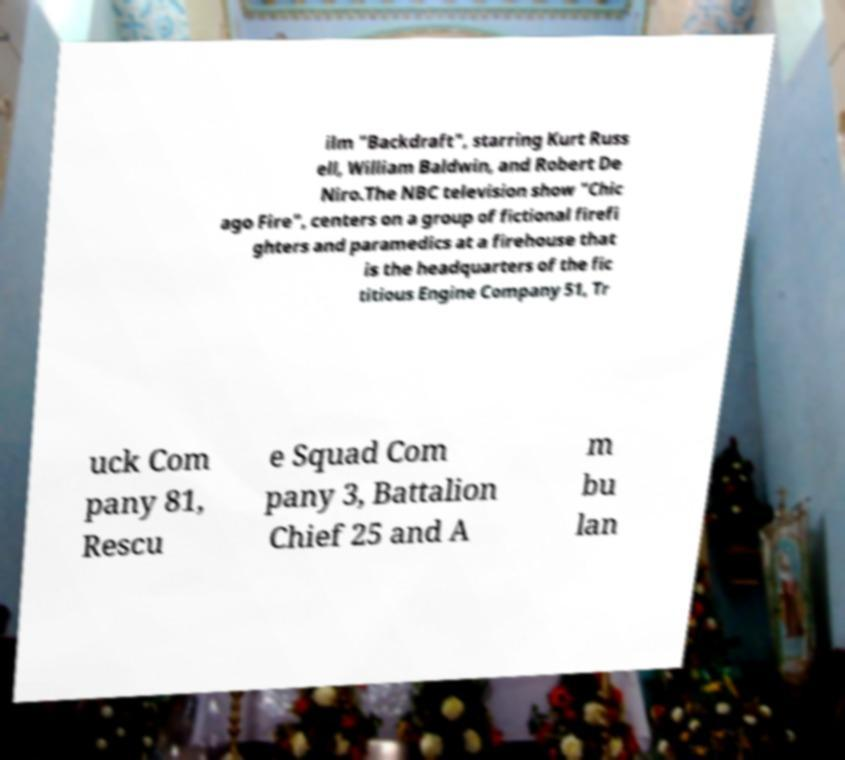Could you extract and type out the text from this image? ilm "Backdraft", starring Kurt Russ ell, William Baldwin, and Robert De Niro.The NBC television show "Chic ago Fire", centers on a group of fictional firefi ghters and paramedics at a firehouse that is the headquarters of the fic titious Engine Company 51, Tr uck Com pany 81, Rescu e Squad Com pany 3, Battalion Chief 25 and A m bu lan 